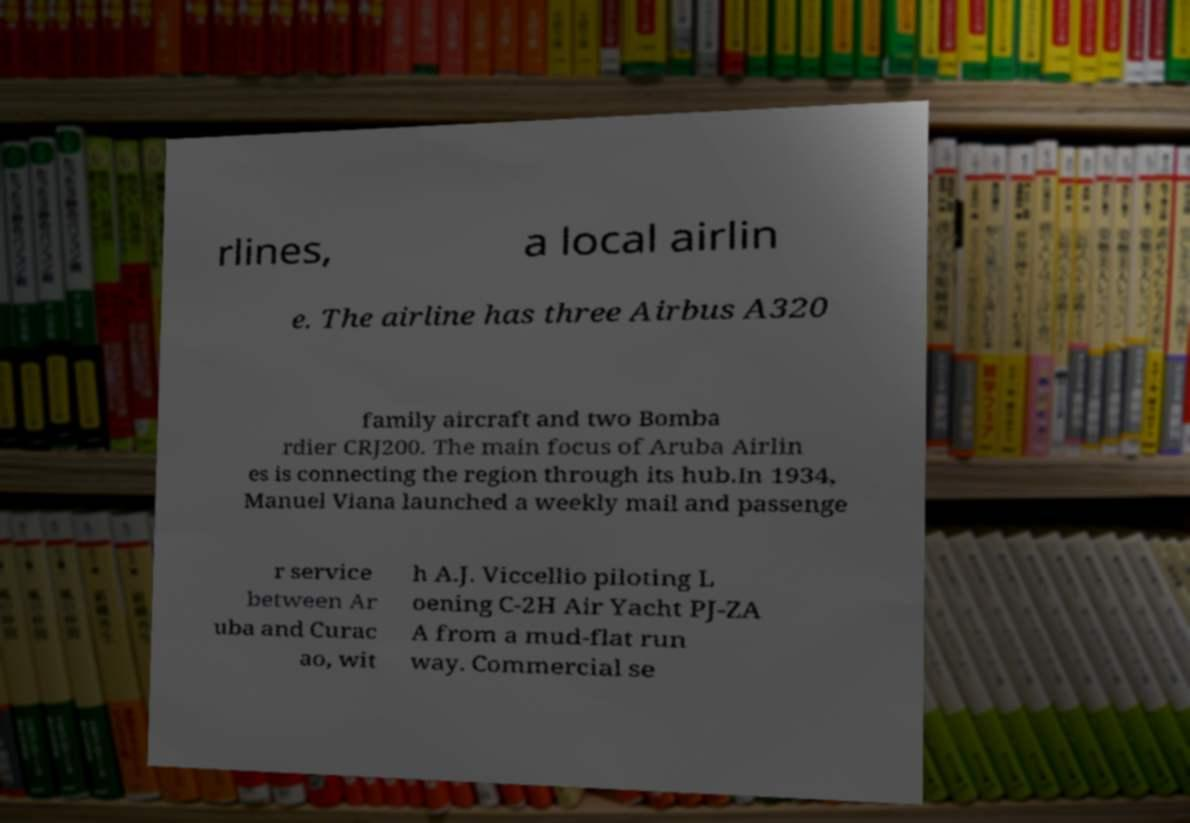For documentation purposes, I need the text within this image transcribed. Could you provide that? rlines, a local airlin e. The airline has three Airbus A320 family aircraft and two Bomba rdier CRJ200. The main focus of Aruba Airlin es is connecting the region through its hub.In 1934, Manuel Viana launched a weekly mail and passenge r service between Ar uba and Curac ao, wit h A.J. Viccellio piloting L oening C-2H Air Yacht PJ-ZA A from a mud-flat run way. Commercial se 